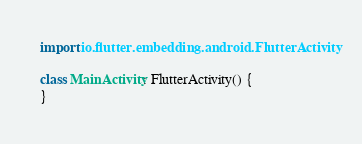Convert code to text. <code><loc_0><loc_0><loc_500><loc_500><_Kotlin_>import io.flutter.embedding.android.FlutterActivity

class MainActivity: FlutterActivity() {
}
</code> 